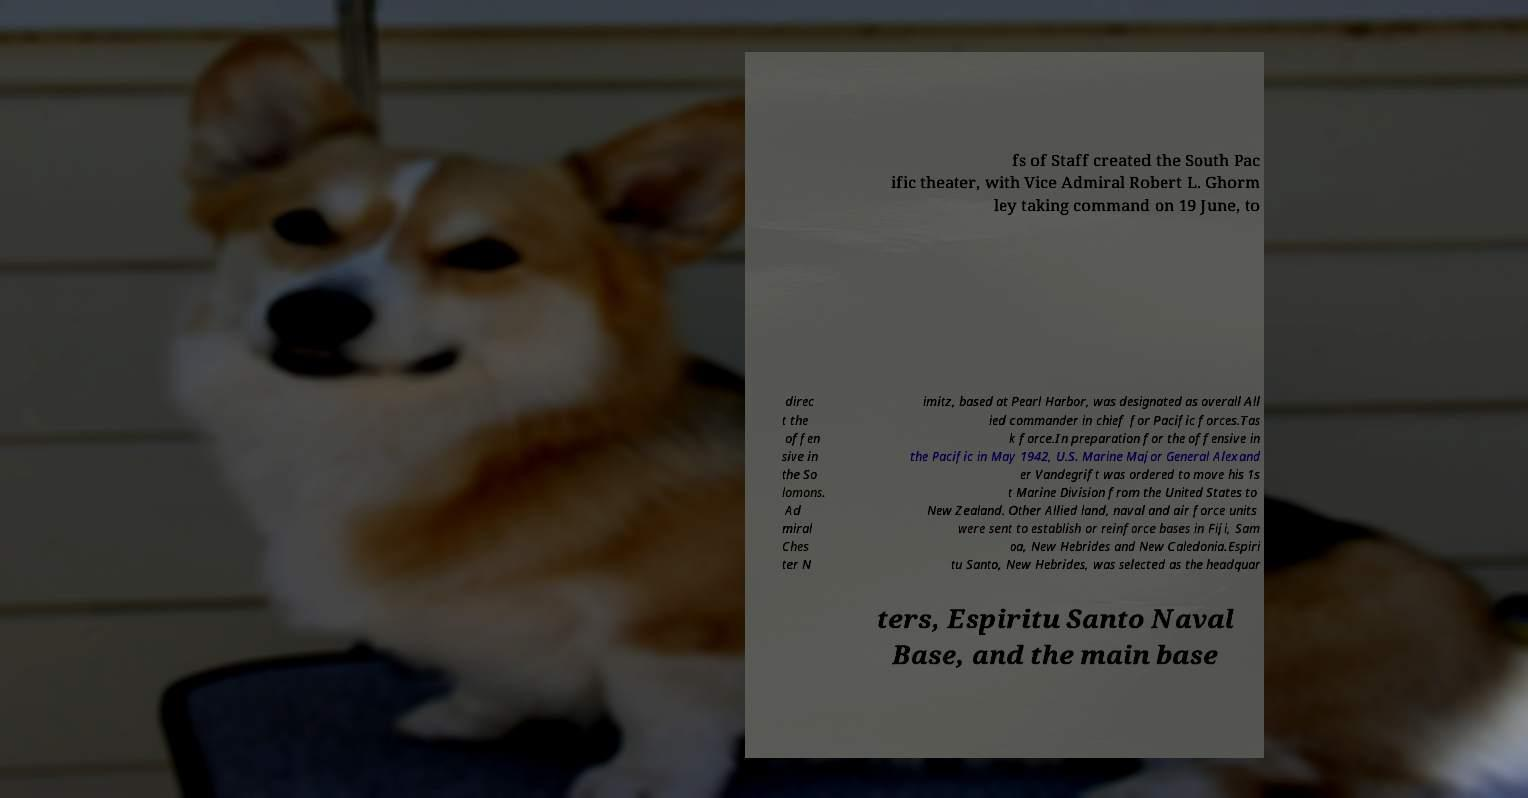For documentation purposes, I need the text within this image transcribed. Could you provide that? fs of Staff created the South Pac ific theater, with Vice Admiral Robert L. Ghorm ley taking command on 19 June, to direc t the offen sive in the So lomons. Ad miral Ches ter N imitz, based at Pearl Harbor, was designated as overall All ied commander in chief for Pacific forces.Tas k force.In preparation for the offensive in the Pacific in May 1942, U.S. Marine Major General Alexand er Vandegrift was ordered to move his 1s t Marine Division from the United States to New Zealand. Other Allied land, naval and air force units were sent to establish or reinforce bases in Fiji, Sam oa, New Hebrides and New Caledonia.Espiri tu Santo, New Hebrides, was selected as the headquar ters, Espiritu Santo Naval Base, and the main base 